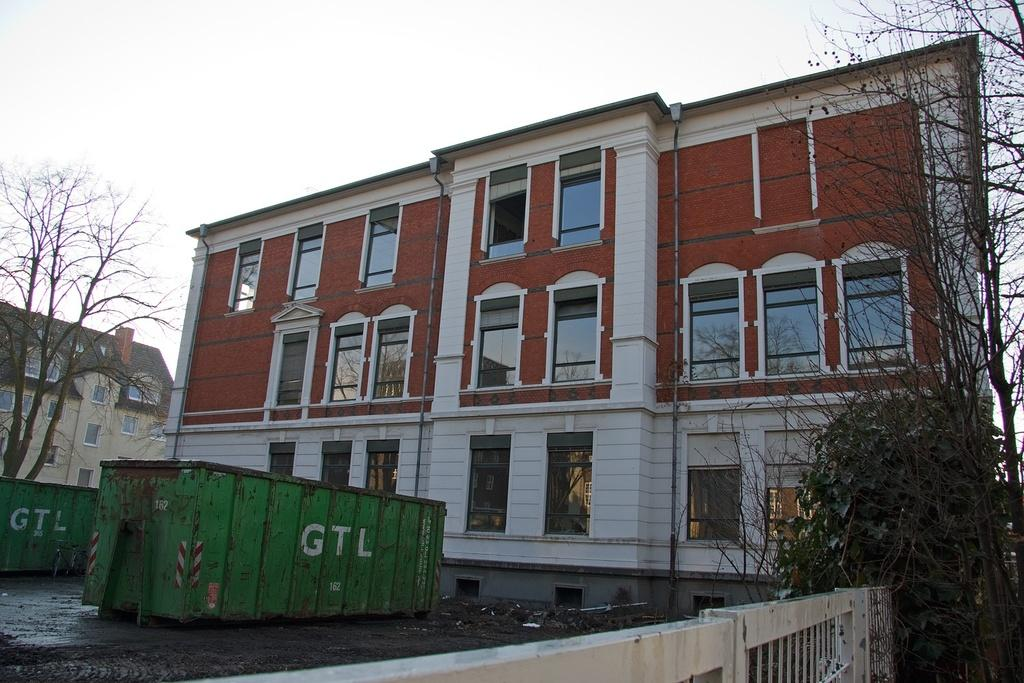What type of structures can be seen in the image? There are buildings in the image. What feature is visible on the buildings? There are windows visible in the image. What type of vegetation is present in the image? There are trees in the image. What objects can be seen in the image that are green in color? There are two green containers in the image. What is the color of the sky in the image? The sky appears to be white in color. How many trees are being used to copy the chalk in the image? There are no trees or chalk present in the image, so this question cannot be answered. 